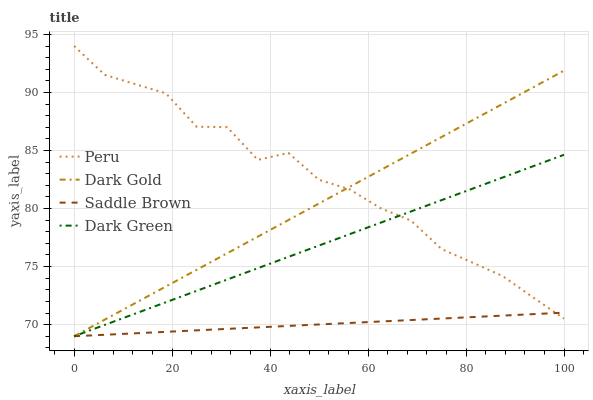Does Saddle Brown have the minimum area under the curve?
Answer yes or no. Yes. Does Peru have the maximum area under the curve?
Answer yes or no. Yes. Does Peru have the minimum area under the curve?
Answer yes or no. No. Does Saddle Brown have the maximum area under the curve?
Answer yes or no. No. Is Saddle Brown the smoothest?
Answer yes or no. Yes. Is Peru the roughest?
Answer yes or no. Yes. Is Peru the smoothest?
Answer yes or no. No. Is Saddle Brown the roughest?
Answer yes or no. No. Does Dark Green have the lowest value?
Answer yes or no. Yes. Does Peru have the lowest value?
Answer yes or no. No. Does Peru have the highest value?
Answer yes or no. Yes. Does Saddle Brown have the highest value?
Answer yes or no. No. Does Peru intersect Saddle Brown?
Answer yes or no. Yes. Is Peru less than Saddle Brown?
Answer yes or no. No. Is Peru greater than Saddle Brown?
Answer yes or no. No. 